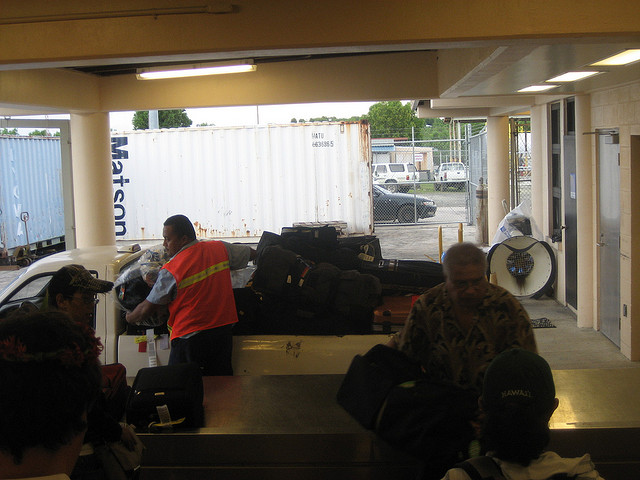Extract all visible text content from this image. Matson 